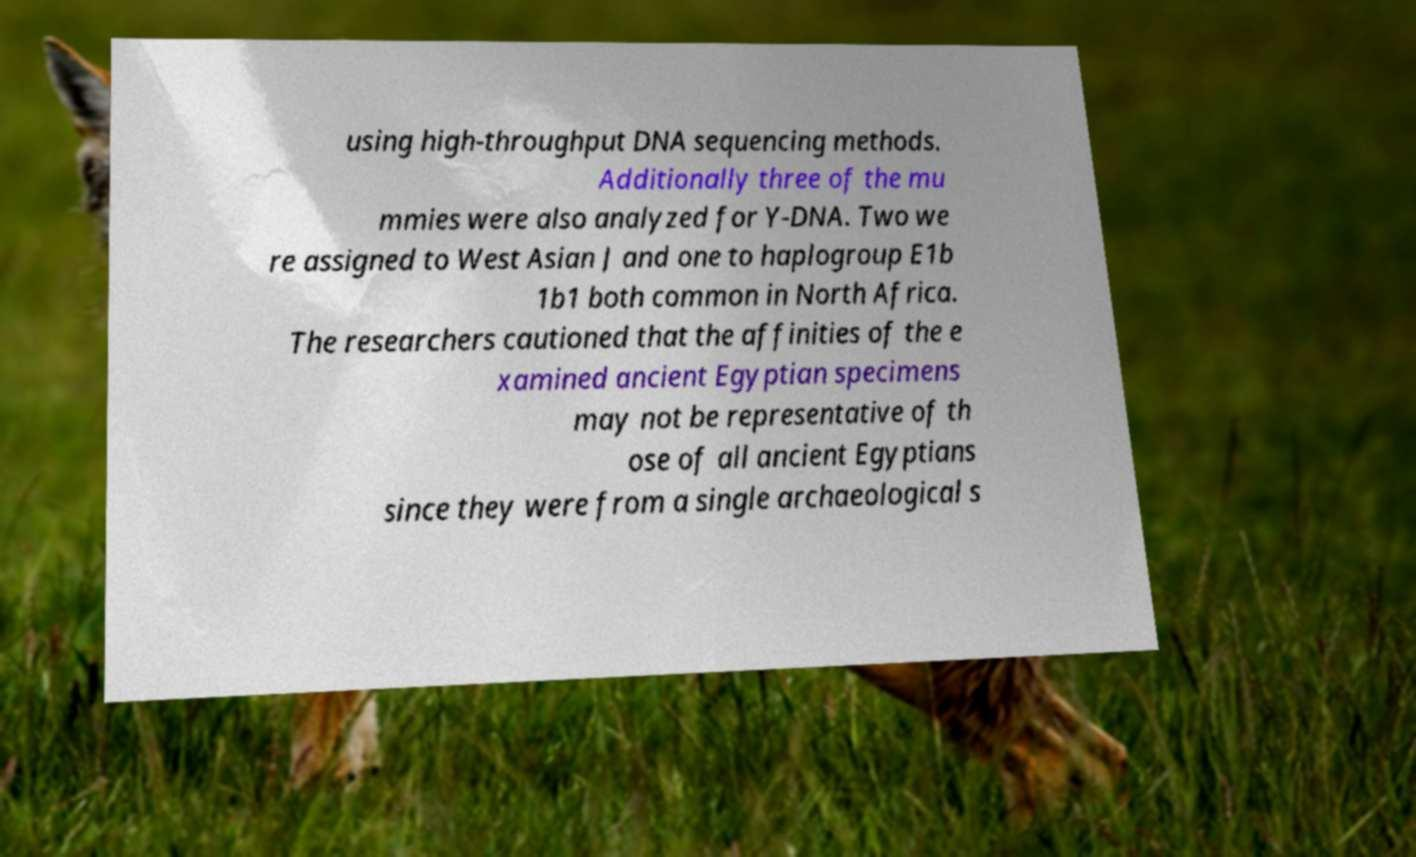Can you accurately transcribe the text from the provided image for me? using high-throughput DNA sequencing methods. Additionally three of the mu mmies were also analyzed for Y-DNA. Two we re assigned to West Asian J and one to haplogroup E1b 1b1 both common in North Africa. The researchers cautioned that the affinities of the e xamined ancient Egyptian specimens may not be representative of th ose of all ancient Egyptians since they were from a single archaeological s 